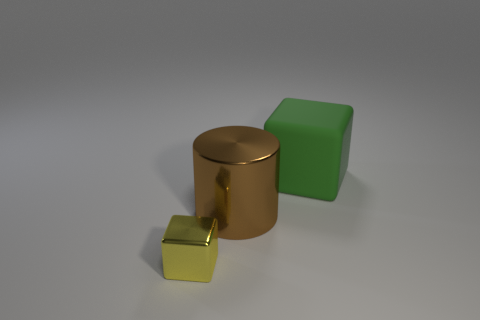Subtract all green blocks. Subtract all blue cylinders. How many blocks are left? 1 Subtract all cyan balls. How many blue cylinders are left? 0 Subtract all small yellow cubes. Subtract all metallic things. How many objects are left? 0 Add 3 big green blocks. How many big green blocks are left? 4 Add 2 large brown rubber things. How many large brown rubber things exist? 2 Add 3 large green blocks. How many objects exist? 6 Subtract all green cubes. How many cubes are left? 1 Subtract 0 yellow balls. How many objects are left? 3 Subtract all cubes. How many objects are left? 1 